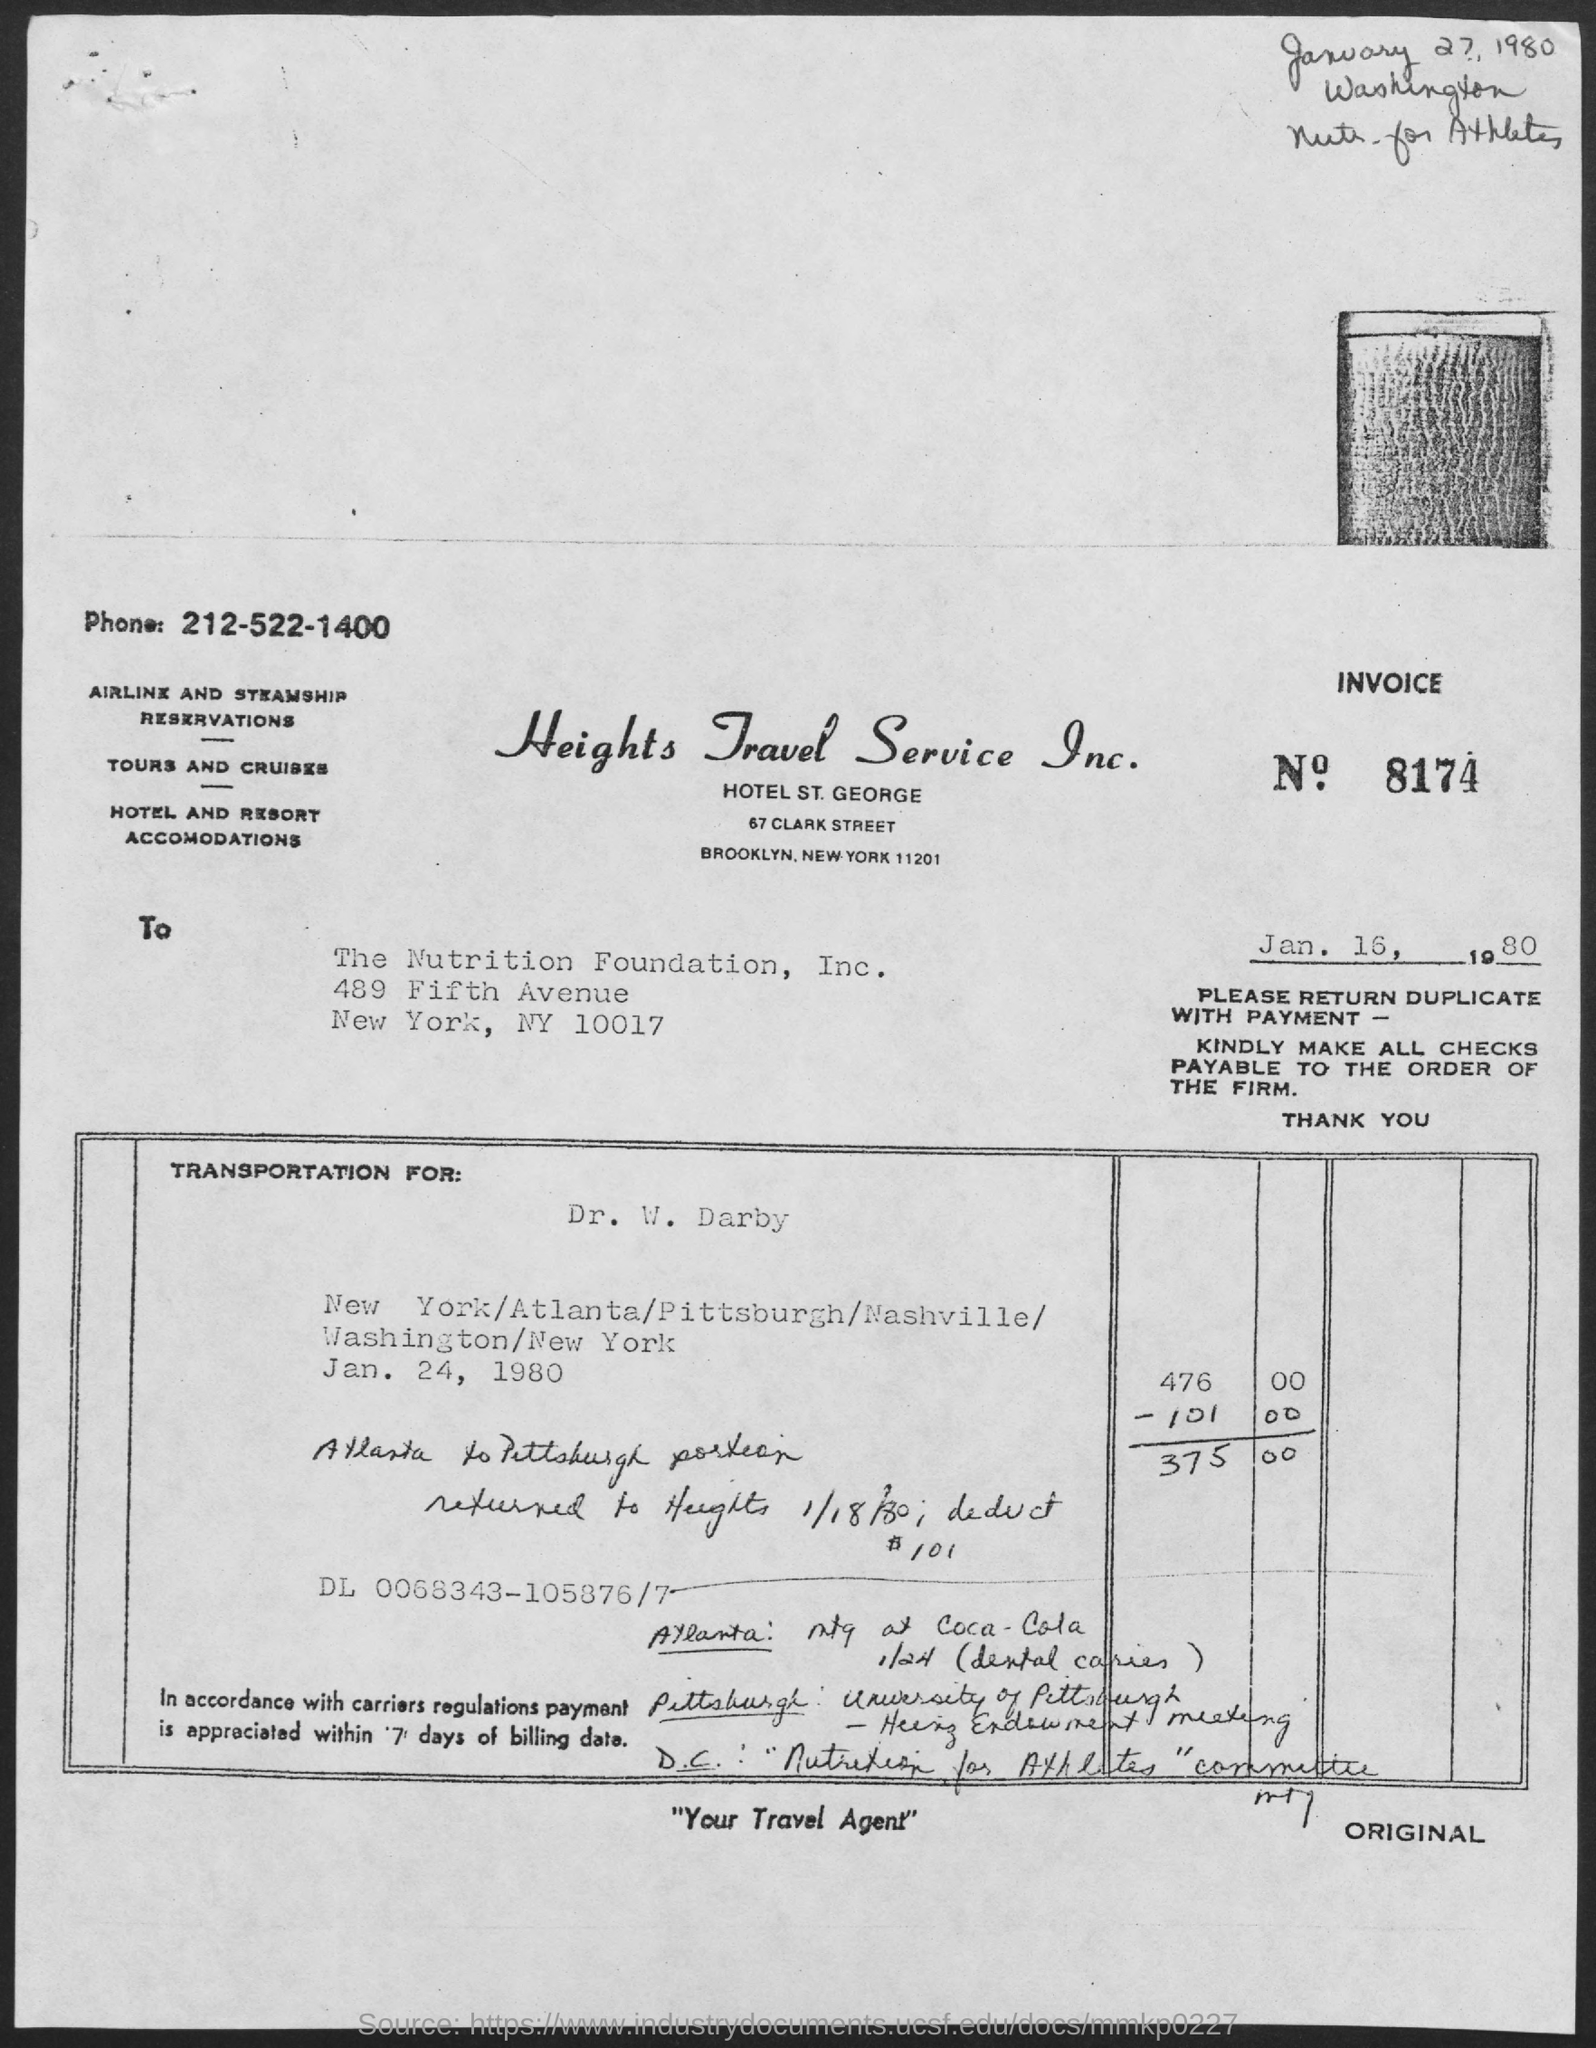What is the invoice no.?
Offer a very short reply. 8174. What is the telephone number of heights travel service inc.?
Your answer should be very brief. 212-522-1400. What is the tagline of heights travel service inc. in quotations below?
Offer a terse response. Your travel agent. 